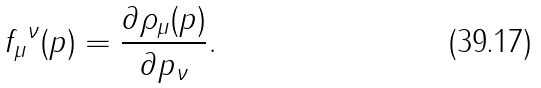Convert formula to latex. <formula><loc_0><loc_0><loc_500><loc_500>f _ { \mu } { ^ { \nu } } ( p ) = \frac { \partial \rho _ { \mu } ( p ) } { \partial p _ { \nu } } .</formula> 